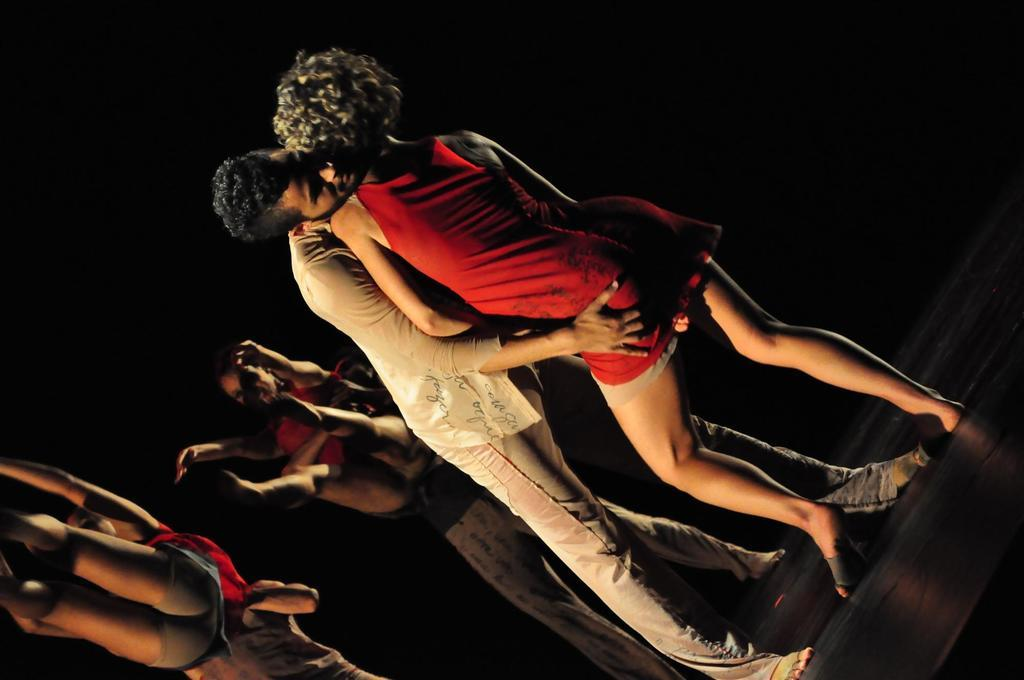How many people are in the image? There are people in the image, but the exact number is not specified. What are the people holding in the image? The people are holding something, but the specific object is not mentioned. What activity are the people engaged in? The people are dancing in the image. How many geese are flying in the image? There is no mention of geese or any flying objects in the image. What type of bean is present in the image? There is no bean present in the image. 